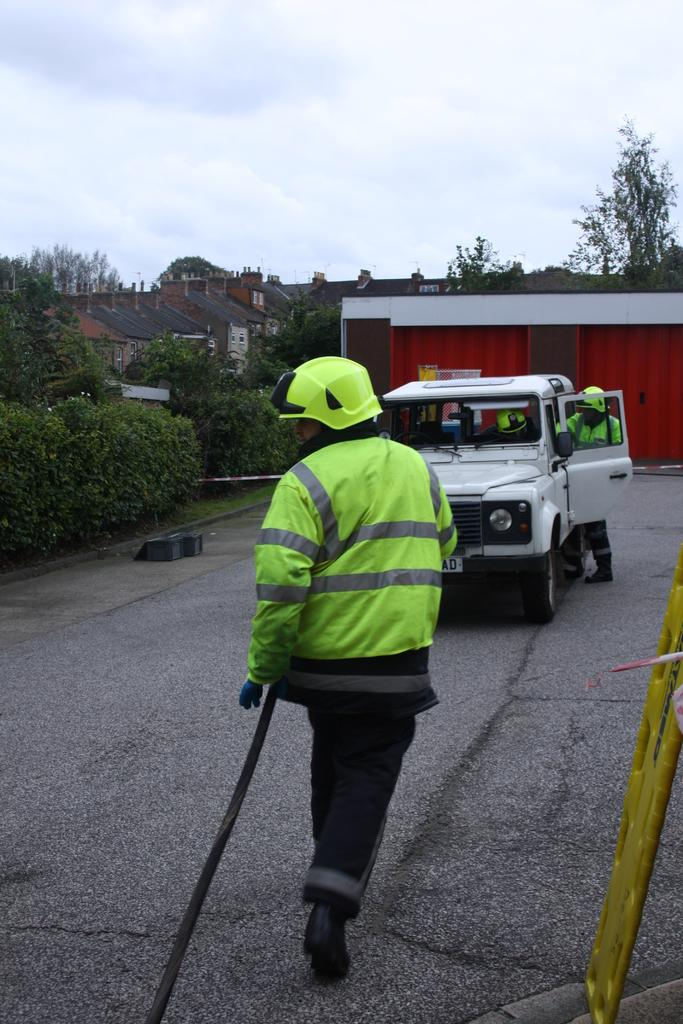What is on the road in the image? There is a vehicle on the road in the image. How many people are in the image? There are three persons in the image. What type of natural elements can be seen in the image? There are plants and trees in the image. What type of man-made structures are visible in the image? There are houses in the image. What is visible in the background of the image? The sky is visible in the background of the image. Can you tell me how many goldfish are swimming in the pond in the image? There is no pond or goldfish present in the image. What type of wish can be granted by the person in the image? There is no mention of wishes or any magical elements in the image. 